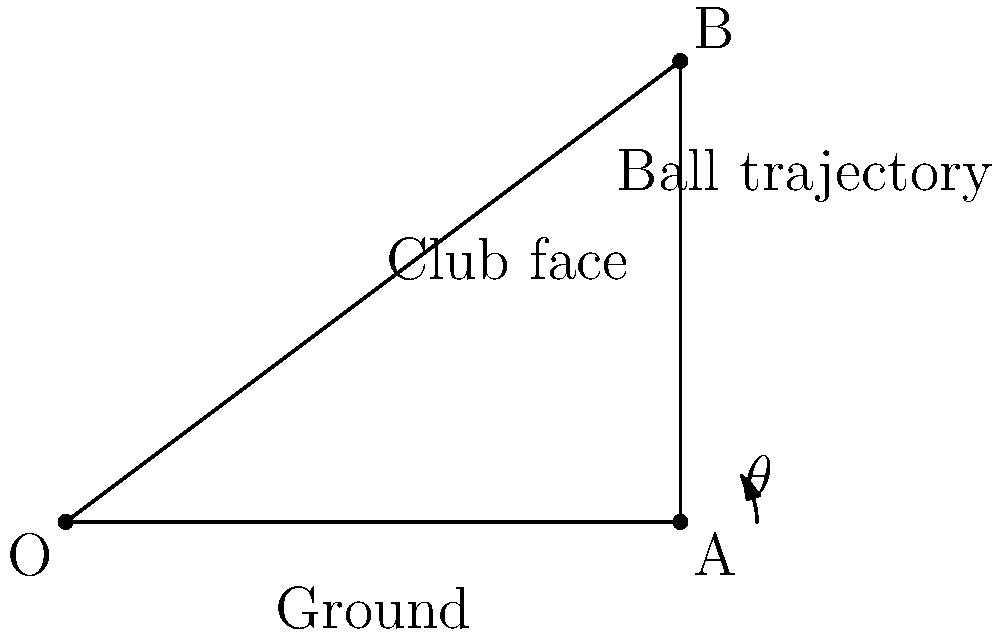As a golf equipment distributor, you're working on optimizing club face angles for maximum distance. Consider a golf club striking a ball at point A, with the ball's initial trajectory represented by line AB. The angle between the ground (OA) and the ball's trajectory (AB) is $\theta$. Given that the optimal launch angle for maximum distance is approximately 36.87°, what should be the angle of the club face relative to the ground to achieve this trajectory, assuming the ball leaves the club face perpendicular to its surface? To solve this problem, we need to understand the relationship between the club face angle and the ball's trajectory. Let's break it down step-by-step:

1) The optimal launch angle for maximum distance is given as 36.87°. This is the angle $\theta$ between the ground (OA) and the ball's trajectory (AB).

2) In golf, the ball typically leaves the club face at a right angle (90°) to the face's surface due to the impact dynamics.

3) Given this, we can determine that the club face should be positioned at half the desired launch angle. This is because:
   - The angle between the club face and the ground forms one part of the right angle.
   - The angle between the club face and the ball's trajectory forms the other part of the right angle.
   - These two angles must sum to 90°, and we want them to be equal for the ball to leave perpendicular to the face.

4) Therefore, the angle of the club face relative to the ground should be:
   $$\frac{36.87°}{2} = 18.435°$$

5) We can verify this:
   - Club face to ground: 18.435°
   - Club face to ball trajectory: 18.435°
   - 18.435° + 18.435° = 36.87°, which is our desired launch angle

Thus, to achieve the optimal launch angle of 36.87°, the club face should be angled at 18.435° relative to the ground.
Answer: 18.435° 